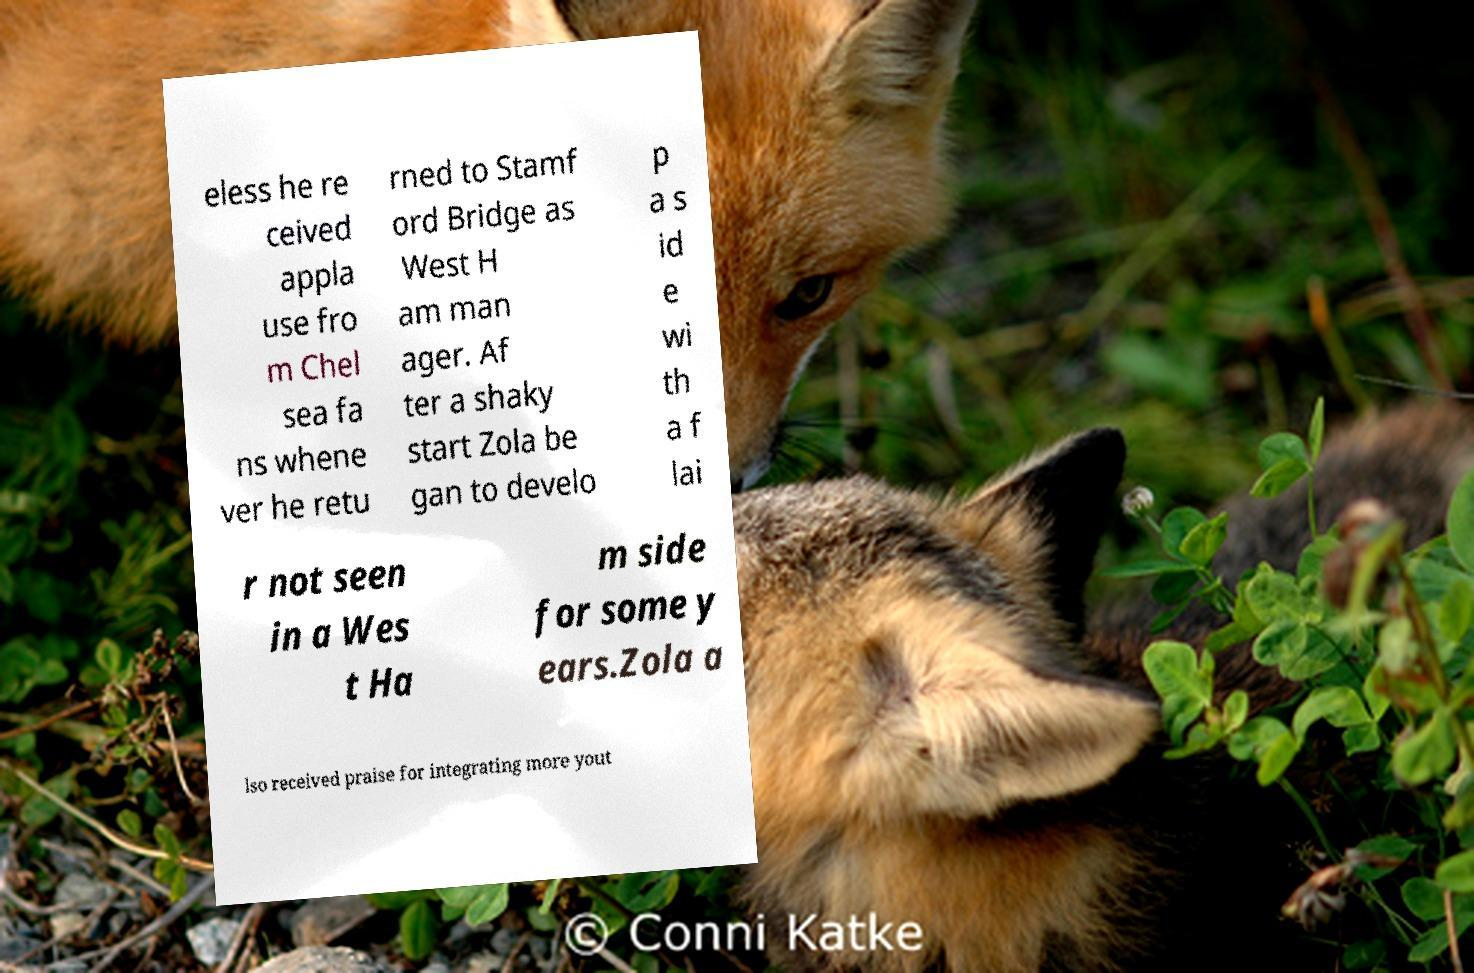There's text embedded in this image that I need extracted. Can you transcribe it verbatim? eless he re ceived appla use fro m Chel sea fa ns whene ver he retu rned to Stamf ord Bridge as West H am man ager. Af ter a shaky start Zola be gan to develo p a s id e wi th a f lai r not seen in a Wes t Ha m side for some y ears.Zola a lso received praise for integrating more yout 